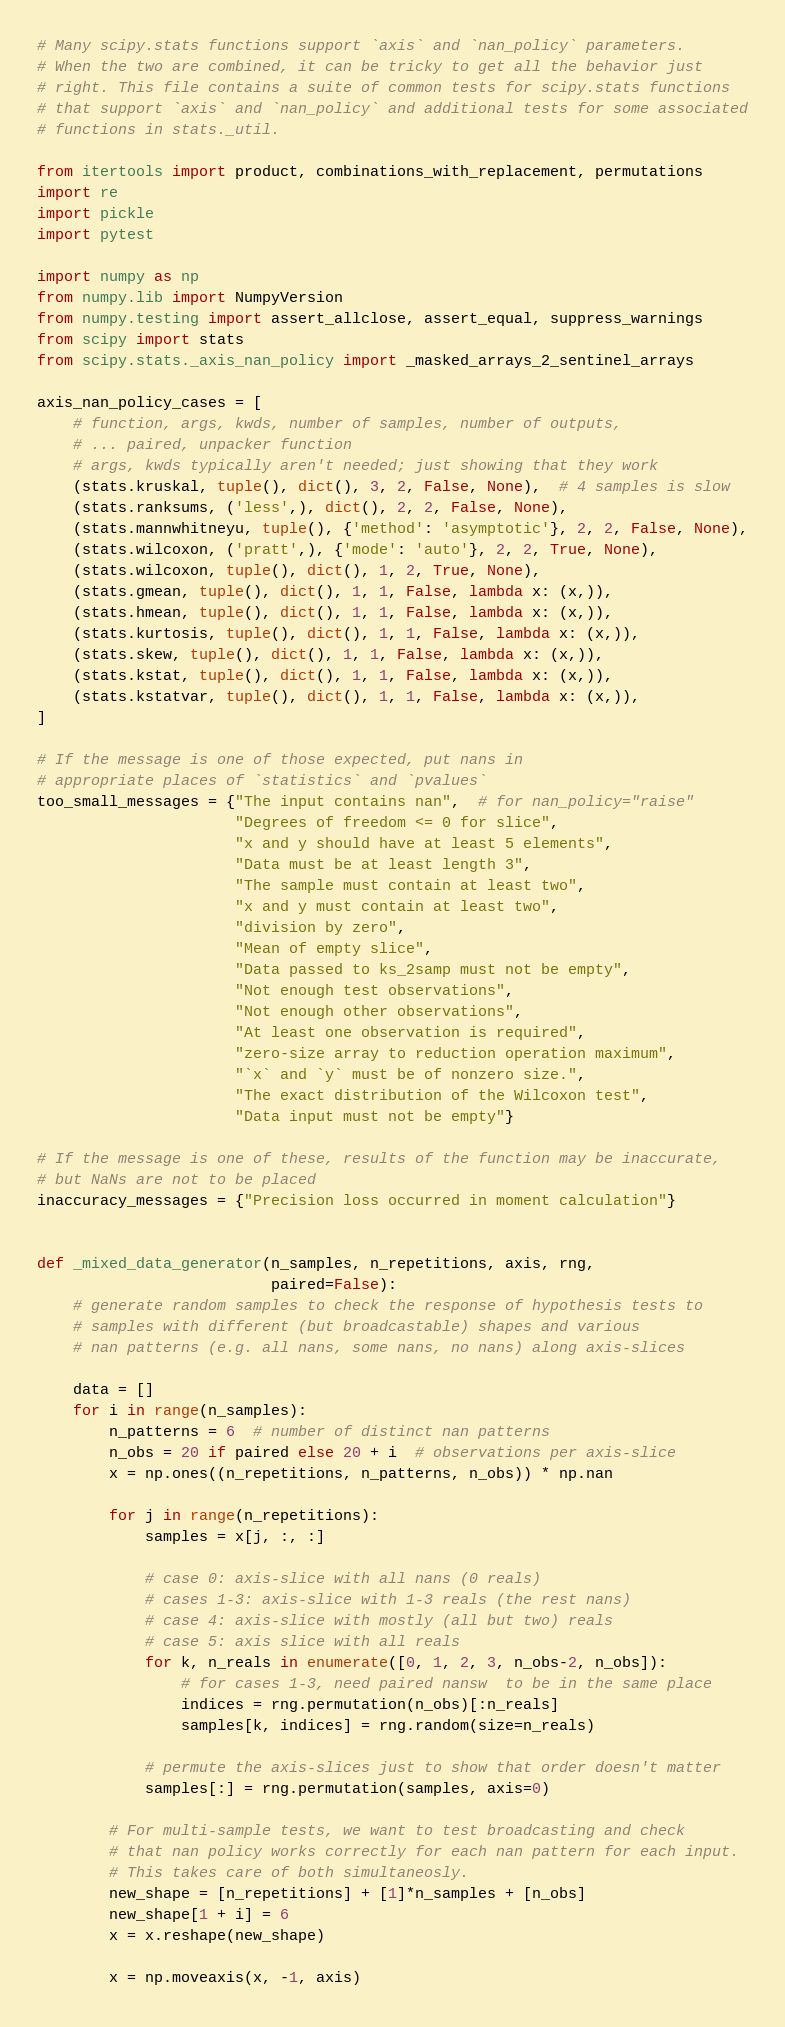<code> <loc_0><loc_0><loc_500><loc_500><_Python_># Many scipy.stats functions support `axis` and `nan_policy` parameters.
# When the two are combined, it can be tricky to get all the behavior just
# right. This file contains a suite of common tests for scipy.stats functions
# that support `axis` and `nan_policy` and additional tests for some associated
# functions in stats._util.

from itertools import product, combinations_with_replacement, permutations
import re
import pickle
import pytest

import numpy as np
from numpy.lib import NumpyVersion
from numpy.testing import assert_allclose, assert_equal, suppress_warnings
from scipy import stats
from scipy.stats._axis_nan_policy import _masked_arrays_2_sentinel_arrays

axis_nan_policy_cases = [
    # function, args, kwds, number of samples, number of outputs,
    # ... paired, unpacker function
    # args, kwds typically aren't needed; just showing that they work
    (stats.kruskal, tuple(), dict(), 3, 2, False, None),  # 4 samples is slow
    (stats.ranksums, ('less',), dict(), 2, 2, False, None),
    (stats.mannwhitneyu, tuple(), {'method': 'asymptotic'}, 2, 2, False, None),
    (stats.wilcoxon, ('pratt',), {'mode': 'auto'}, 2, 2, True, None),
    (stats.wilcoxon, tuple(), dict(), 1, 2, True, None),
    (stats.gmean, tuple(), dict(), 1, 1, False, lambda x: (x,)),
    (stats.hmean, tuple(), dict(), 1, 1, False, lambda x: (x,)),
    (stats.kurtosis, tuple(), dict(), 1, 1, False, lambda x: (x,)),
    (stats.skew, tuple(), dict(), 1, 1, False, lambda x: (x,)),
    (stats.kstat, tuple(), dict(), 1, 1, False, lambda x: (x,)),
    (stats.kstatvar, tuple(), dict(), 1, 1, False, lambda x: (x,)),
]

# If the message is one of those expected, put nans in
# appropriate places of `statistics` and `pvalues`
too_small_messages = {"The input contains nan",  # for nan_policy="raise"
                      "Degrees of freedom <= 0 for slice",
                      "x and y should have at least 5 elements",
                      "Data must be at least length 3",
                      "The sample must contain at least two",
                      "x and y must contain at least two",
                      "division by zero",
                      "Mean of empty slice",
                      "Data passed to ks_2samp must not be empty",
                      "Not enough test observations",
                      "Not enough other observations",
                      "At least one observation is required",
                      "zero-size array to reduction operation maximum",
                      "`x` and `y` must be of nonzero size.",
                      "The exact distribution of the Wilcoxon test",
                      "Data input must not be empty"}

# If the message is one of these, results of the function may be inaccurate,
# but NaNs are not to be placed
inaccuracy_messages = {"Precision loss occurred in moment calculation"}


def _mixed_data_generator(n_samples, n_repetitions, axis, rng,
                          paired=False):
    # generate random samples to check the response of hypothesis tests to
    # samples with different (but broadcastable) shapes and various
    # nan patterns (e.g. all nans, some nans, no nans) along axis-slices

    data = []
    for i in range(n_samples):
        n_patterns = 6  # number of distinct nan patterns
        n_obs = 20 if paired else 20 + i  # observations per axis-slice
        x = np.ones((n_repetitions, n_patterns, n_obs)) * np.nan

        for j in range(n_repetitions):
            samples = x[j, :, :]

            # case 0: axis-slice with all nans (0 reals)
            # cases 1-3: axis-slice with 1-3 reals (the rest nans)
            # case 4: axis-slice with mostly (all but two) reals
            # case 5: axis slice with all reals
            for k, n_reals in enumerate([0, 1, 2, 3, n_obs-2, n_obs]):
                # for cases 1-3, need paired nansw  to be in the same place
                indices = rng.permutation(n_obs)[:n_reals]
                samples[k, indices] = rng.random(size=n_reals)

            # permute the axis-slices just to show that order doesn't matter
            samples[:] = rng.permutation(samples, axis=0)

        # For multi-sample tests, we want to test broadcasting and check
        # that nan policy works correctly for each nan pattern for each input.
        # This takes care of both simultaneosly.
        new_shape = [n_repetitions] + [1]*n_samples + [n_obs]
        new_shape[1 + i] = 6
        x = x.reshape(new_shape)

        x = np.moveaxis(x, -1, axis)</code> 